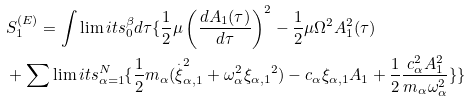Convert formula to latex. <formula><loc_0><loc_0><loc_500><loc_500>& S _ { 1 } ^ { ( E ) } = \int \lim i t s _ { 0 } ^ { \beta } d \tau \{ \frac { 1 } { 2 } \mu \left ( \frac { d A _ { 1 } ( \tau ) } { d \tau } \right ) ^ { 2 } - \frac { 1 } { 2 } \mu \Omega ^ { 2 } A _ { 1 } ^ { 2 } ( \tau ) \\ & + \sum \lim i t s _ { \alpha = 1 } ^ { N } \{ \frac { 1 } { 2 } m _ { \alpha } ( \overset { . } \xi _ { \alpha , 1 } ^ { 2 } + \omega _ { \alpha } ^ { 2 } { { \xi } _ { \alpha , 1 } } ^ { 2 } ) - c _ { \alpha } \xi _ { \alpha , 1 } A _ { 1 } + \frac { 1 } { 2 } \frac { c _ { \alpha } ^ { 2 } A _ { 1 } ^ { 2 } } { m _ { \alpha } \omega _ { \alpha } ^ { 2 } } \} \}</formula> 